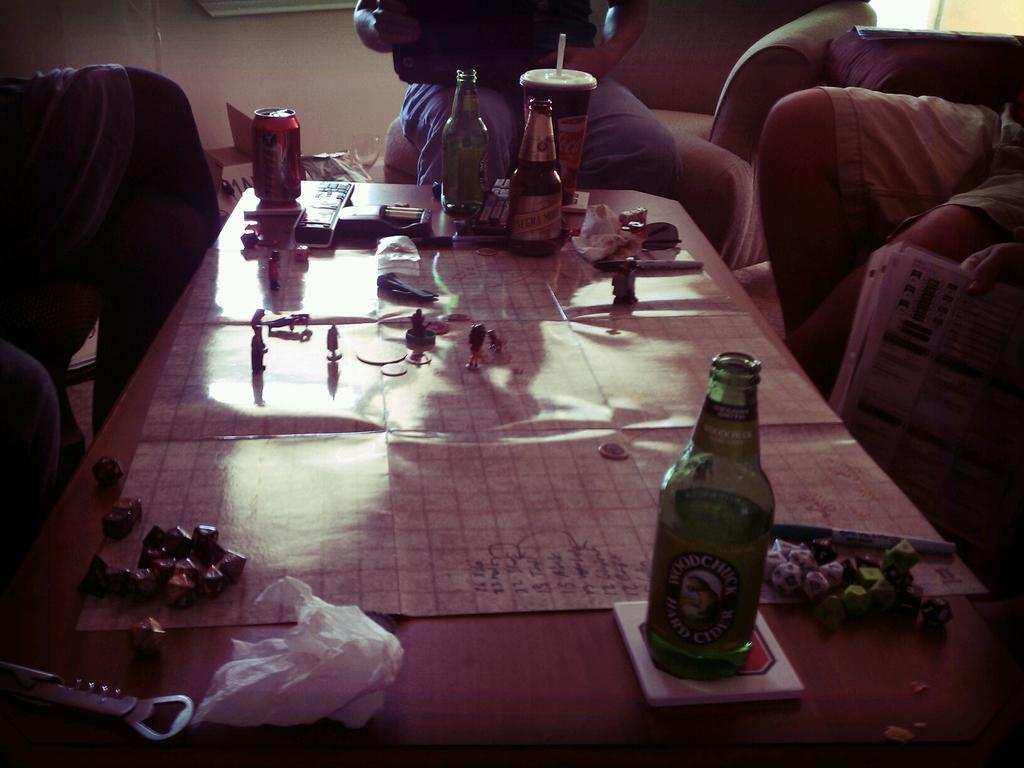Can you describe this image briefly? In this image i can see a bottle,food items,fork,cigarettes,remote and coke tin on top of the table and at the background of the image there are two persons sitting. 